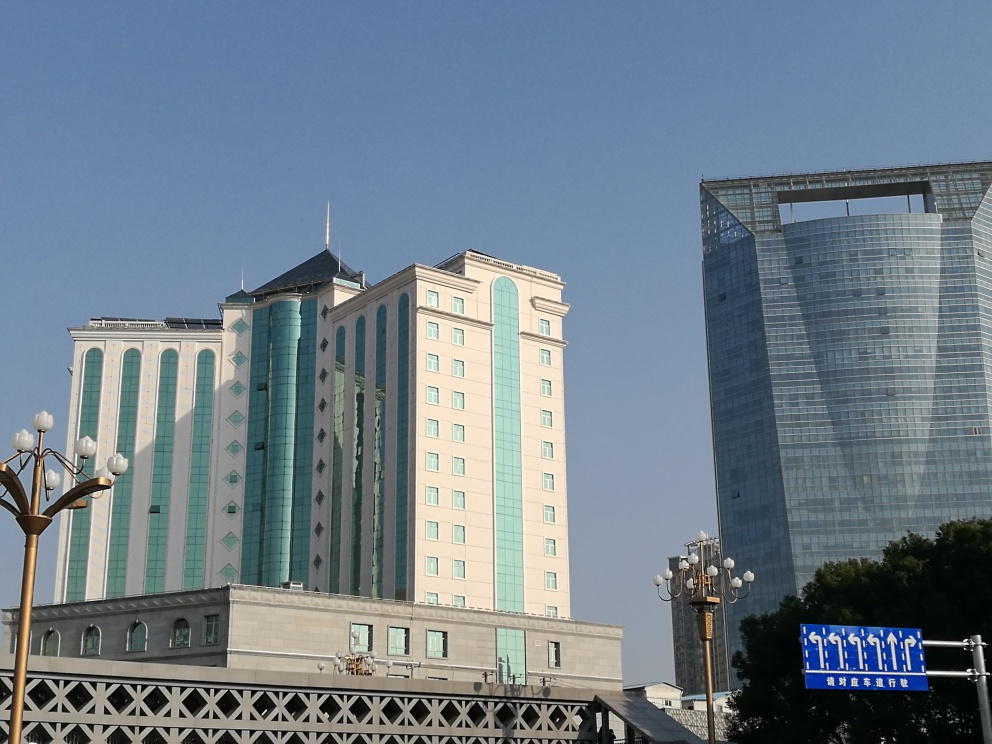Are the colors of the image good? The colors in the image provide a natural and realistic portrayal of the scene, with the clear blue sky complementing the various shades seen on the buildings' facades. The contrast between the warm beige tones of the older building and the reflective glass surface of the modern skyscraper adds a dynamic vibrancy to the image. 